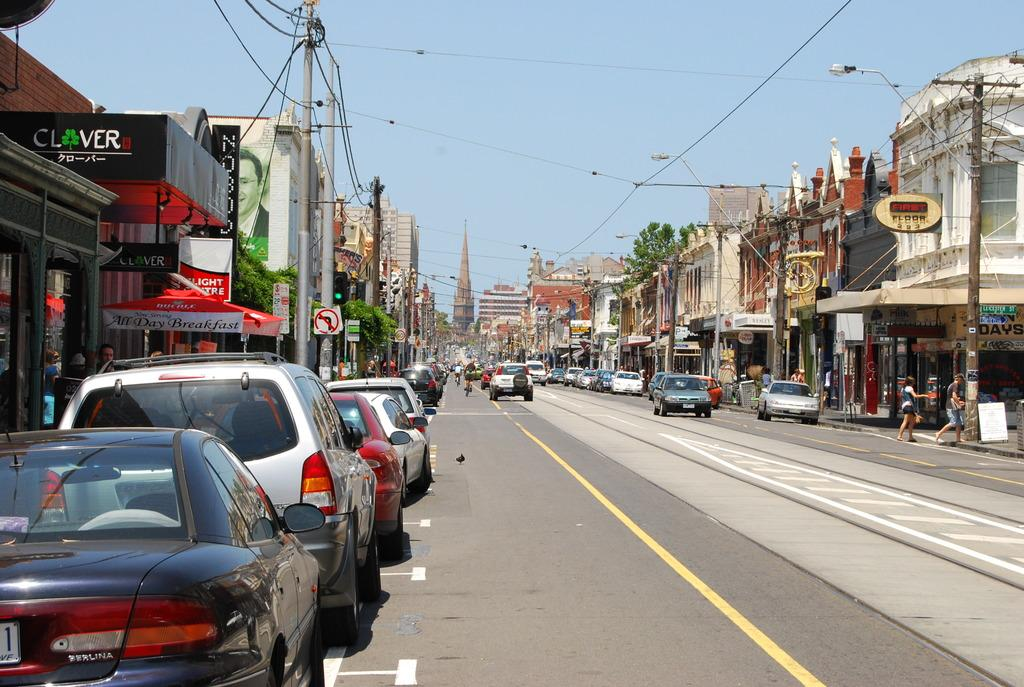<image>
Provide a brief description of the given image. A street with cars parked on the side of the road in front of a storefront that says Clover. 